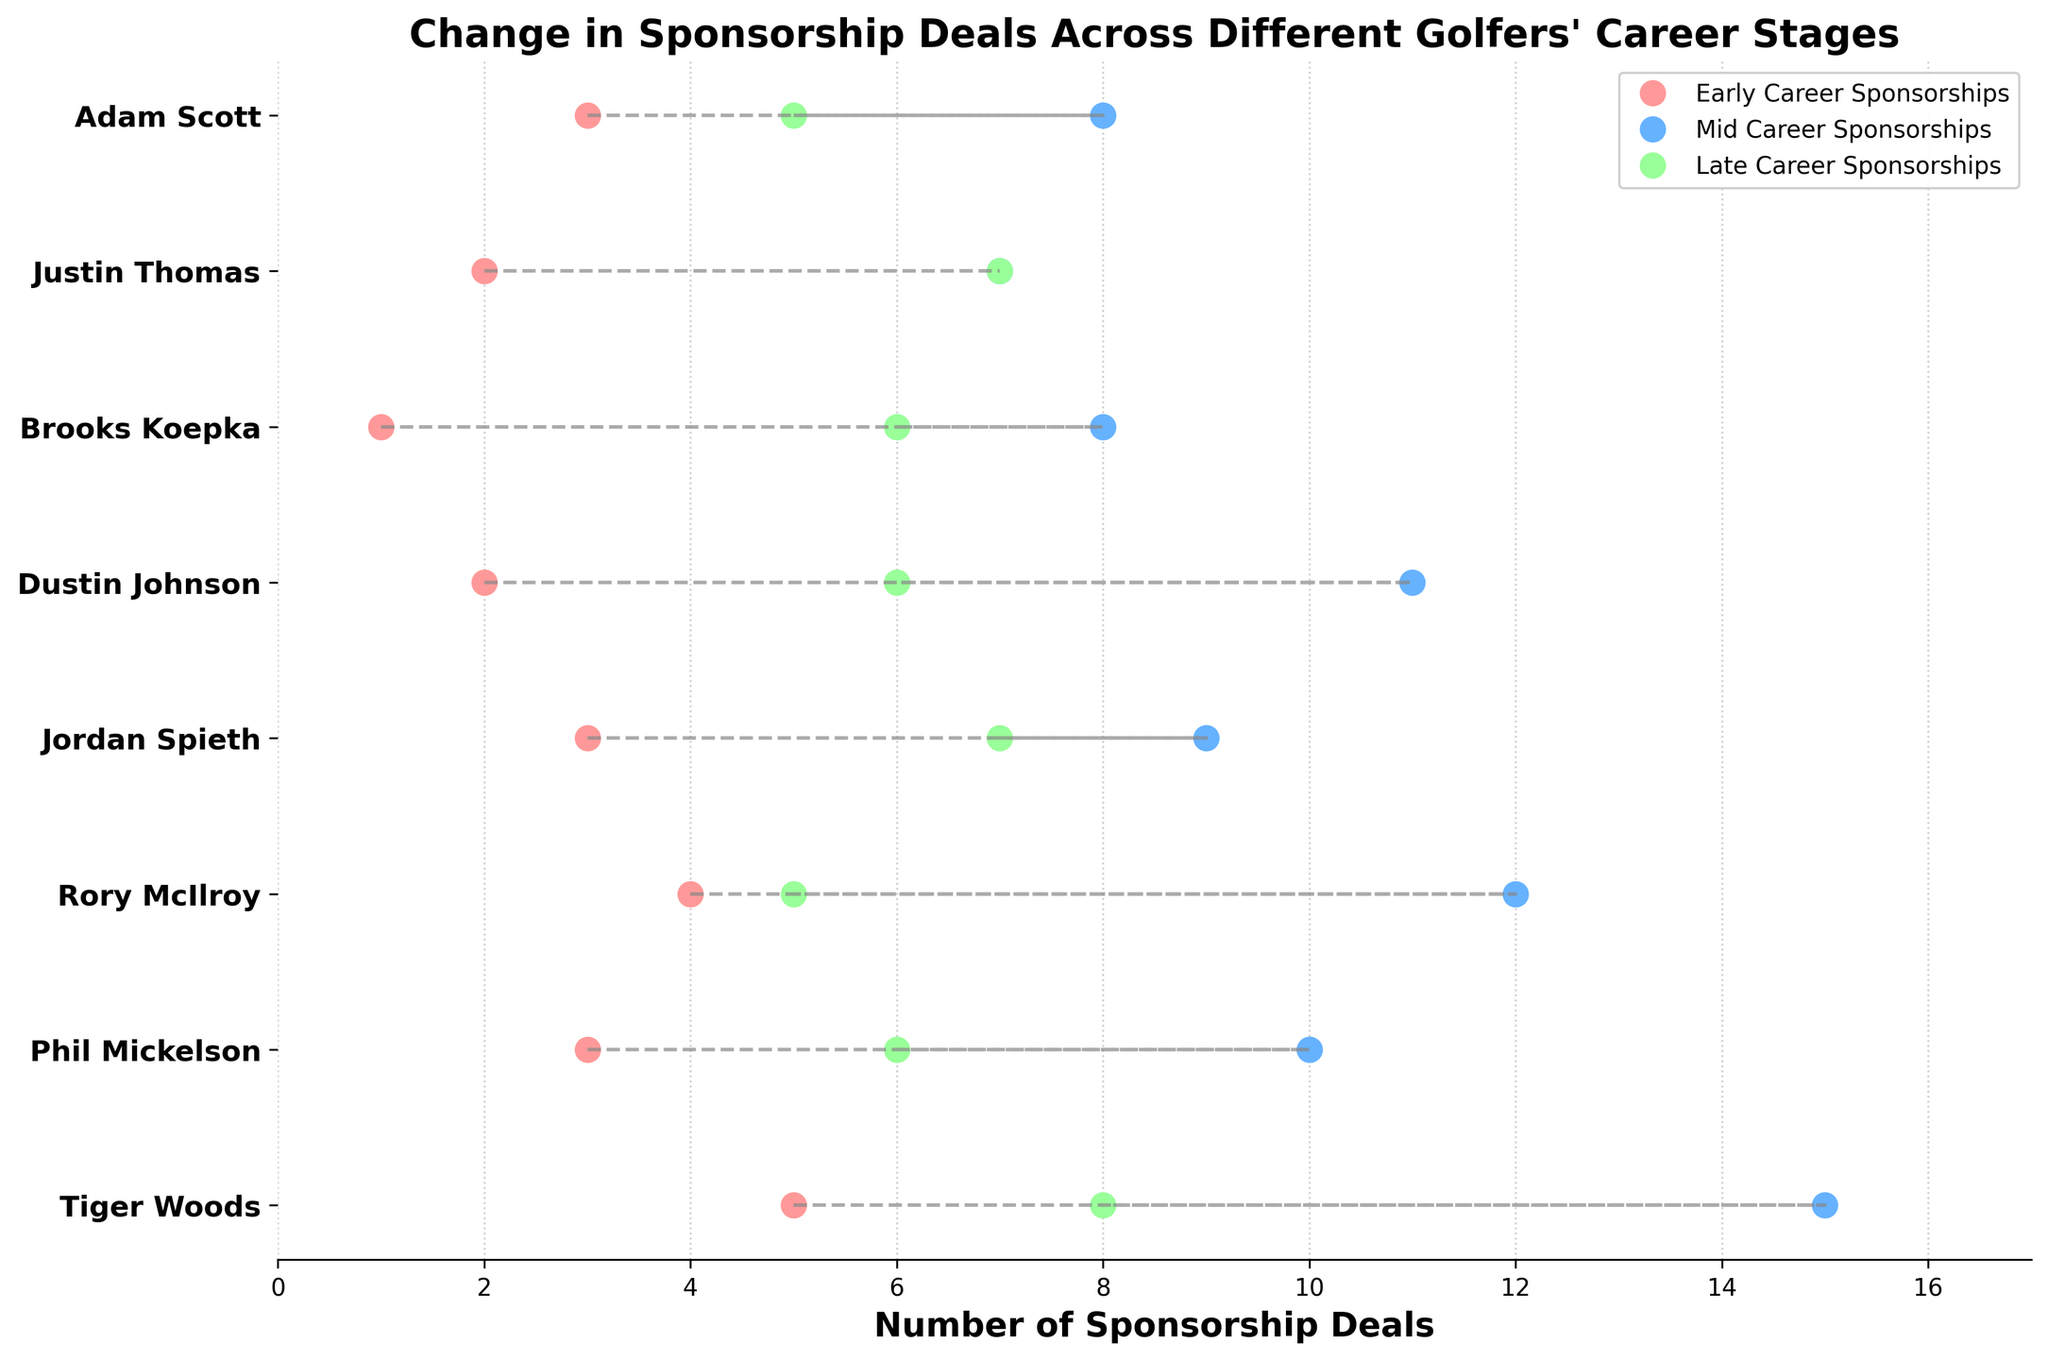what is the title of the figure? The title is located at the top of the figure in large, bold text, summarizing what the plot is about.
Answer: Change in Sponsorship Deals Across Different Golfers' Career Stages which golfer has the highest number of mid-career sponsorships? Look for the golfer with the highest marker point on the "Mid Career Sponsorships" line.
Answer: Tiger Woods how many sponsorship deals did Rory McIlroy have in his early career? Find Rory McIlroy on the y-axis and look for the corresponding point on the "Early Career Sponsorships" line.
Answer: 4 what is the average number of early career sponsorships for all golfers? Add up the early career sponsorships for all golfers (5 + 3 + 4 + 3 + 2 + 1 + 2 + 3 = 23) and divide by the number of golfers (8). 23/8 = 2.875
Answer: 2.88 who experienced the largest increase in sponsorship deals from early career to mid career? Calculate the difference between early and mid-career sponsorships for each golfer and find the maximum value.
Answer: Tiger Woods does Jordan Spieth have more late career or mid career sponsorships? Compare the markers for Jordan Spieth between "Mid Career Sponsorships" and "Late Career Sponsorships."
Answer: Mid Career which golfer has the smallest change in sponsorship deals between career stages? For each golfer, observe the length of the lines connecting their markers; the shortest line indicates the smallest change.
Answer: Justin Thomas how many golfers have more than 10 mid-career sponsorships? Count the number of golfers whose "Mid Career Sponsorships" markers are positioned at or above 10.
Answer: 4 compare the late career sponsorships of Phil Mickelson and Dustin Johnson. Who has more? Examine the "Late Career Sponsorships" markers for both golfers to see who has the higher value.
Answer: Phil Mickelson what color represents early career sponsorships in the figure? Identify the color used for the markers representing "Early Career Sponsorships".
Answer: Light Red 